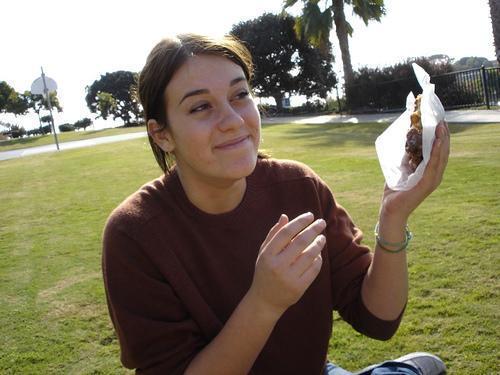How many green bracelets are there?
Give a very brief answer. 1. 